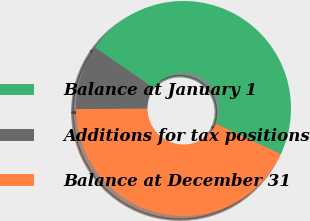Convert chart to OTSL. <chart><loc_0><loc_0><loc_500><loc_500><pie_chart><fcel>Balance at January 1<fcel>Additions for tax positions<fcel>Balance at December 31<nl><fcel>47.39%<fcel>9.68%<fcel>42.93%<nl></chart> 